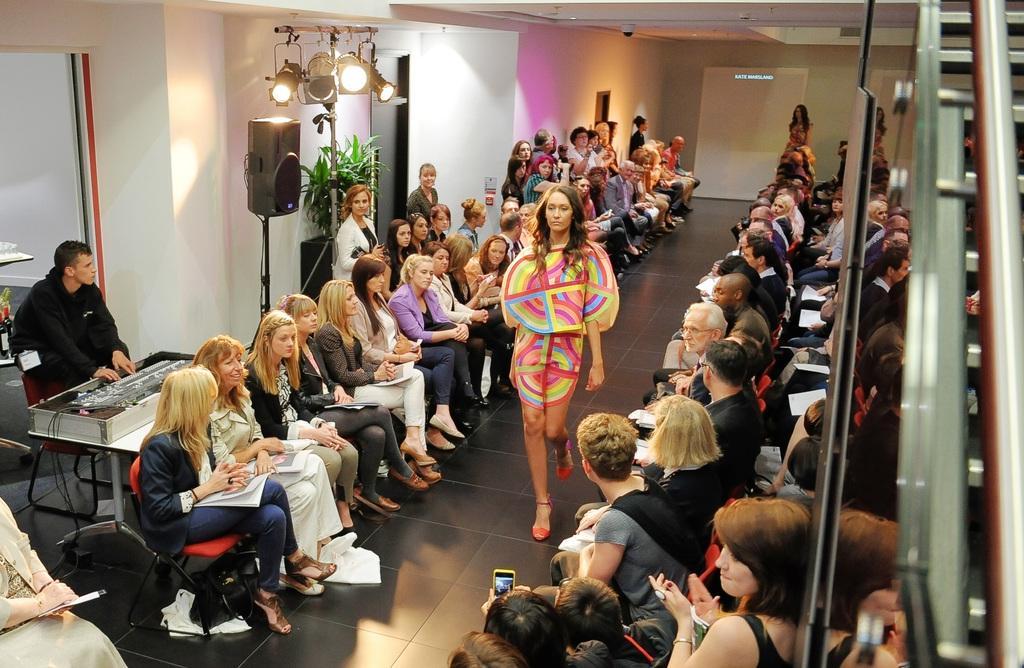How would you summarize this image in a sentence or two? In this picture I can observe a woman walking in this path on the floor. She is wearing different colors of dress. On either sides of the women there are some people sitting in the chairs. There are men and women in this picture. On the right side I can observe a speaker and lights. In the background there is a wall. 